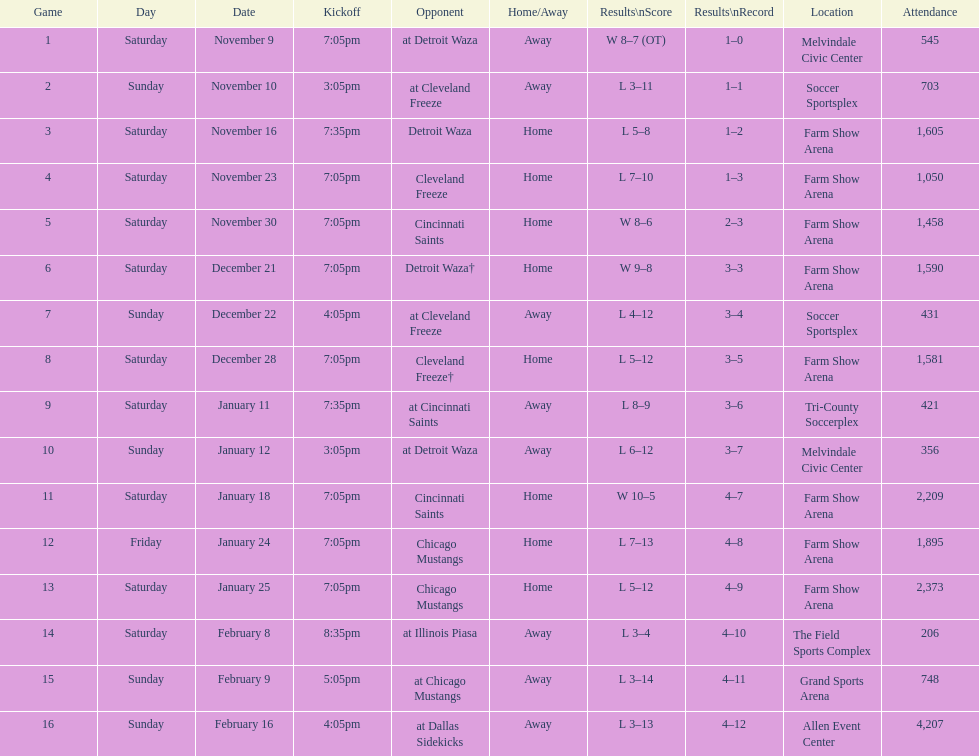Which opponent is listed after cleveland freeze in the table? Detroit Waza. 